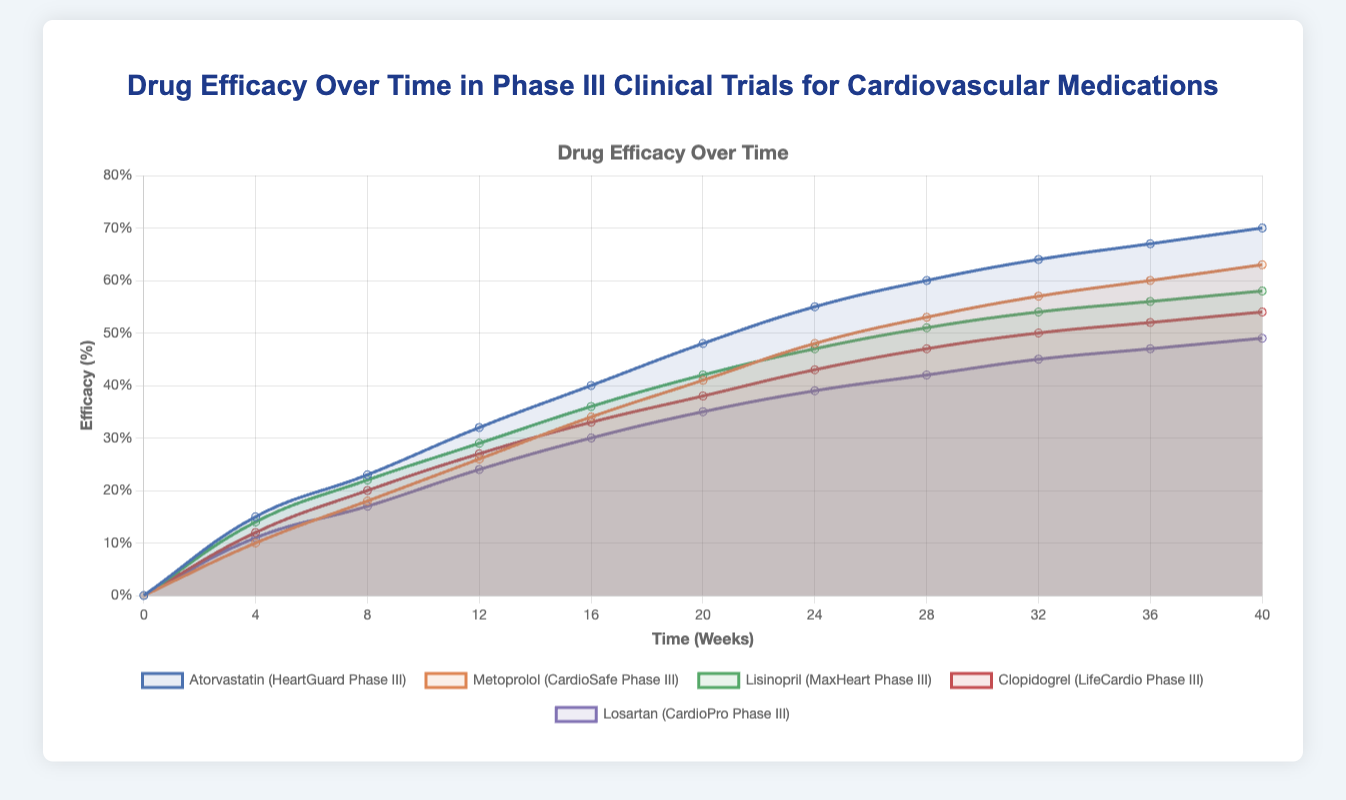Which drug shows the highest efficacy at the 24-week mark? At 24 weeks, identify the drug with the highest efficacy percentage by comparing the data values given for each drug. The highest efficacy percentage at 24 weeks is represented by Atorvastatin at 55%.
Answer: Atorvastatin Which drug shows the lowest overall efficacy at the end of the 40-week period? At the 40-week mark, compare all efficacy percentages across the drugs. Losartan shows the lowest efficacy percentage at 49%.
Answer: Losartan What is the total increase in efficacy for Clopidogrel from week 0 to week 40? Subtract the initial efficacy (week 0) from the final efficacy (week 40) for Clopidogrel: \( 54 - 0 = 54 \)
Answer: 54% Which two drugs have the closest efficacy percentages at the 16-week mark, and what are their values? Compare the efficacy percentages of all drugs at 16 weeks. The closest efficacy percentages are between Lisinopril (36%) and Clopidogrel (33%), with a difference of 3%.
Answer: Lisinopril (36%) and Clopidogrel (33%) How much more efficacy does Atorvastatin have compared to Losartan at the 12-week mark? Subtract Losartan's efficacy (24%) from Atorvastatin's efficacy (32%) at the 12-week mark: \( 32 - 24 = 8 \)
Answer: 8% Across all time points, which drug exhibits the most consistent increase in efficacy? By visually inspecting the plot, observe the smoothness and uniformity of the increase across time points. Metoprolol demonstrates the most consistent increase in efficacy over time.
Answer: Metoprolol Which drug experienced the largest percentage increase in efficacy between the 8th and 12th weeks? Calculate the percentage increase for each drug between weeks 8 and 12. Atorvastatin increased from 23% to 32%, resulting in a change of \( 32 - 23 = 9\%. \) This is the largest increase comparing it to the other drugs.
Answer: Atorvastatin What is the average efficacy of Metoprolol measured at week 0, week 20, and week 40? Add the efficacy percentages of Metoprolol at these time points (0, 41, 63) and divide by the number of points: \( \frac{0 + 41 + 63}{3} = \frac{104}{3} \approx 34.67 \)
Answer: 34.67% Between weeks 20 and 24, which drug exhibits the smallest change in efficacy? Calculate the change in efficacy for each drug between weeks 20 and 24, noting Clopidogrel changes from 38% to 43%, showing a change of 5%, the smallest among the drugs.
Answer: Clopidogrel 